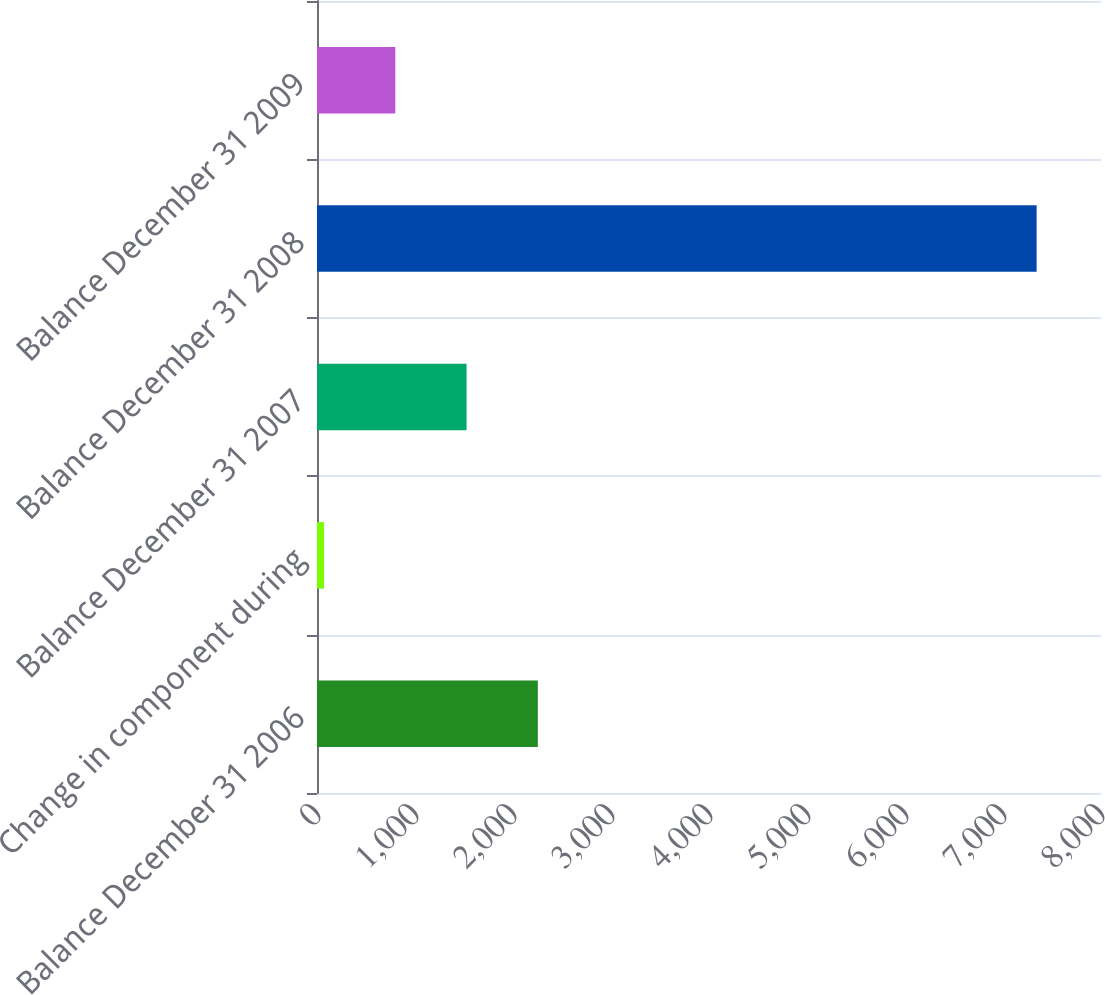Convert chart to OTSL. <chart><loc_0><loc_0><loc_500><loc_500><bar_chart><fcel>Balance December 31 2006<fcel>Change in component during<fcel>Balance December 31 2007<fcel>Balance December 31 2008<fcel>Balance December 31 2009<nl><fcel>2253.3<fcel>72<fcel>1526.2<fcel>7343<fcel>799.1<nl></chart> 